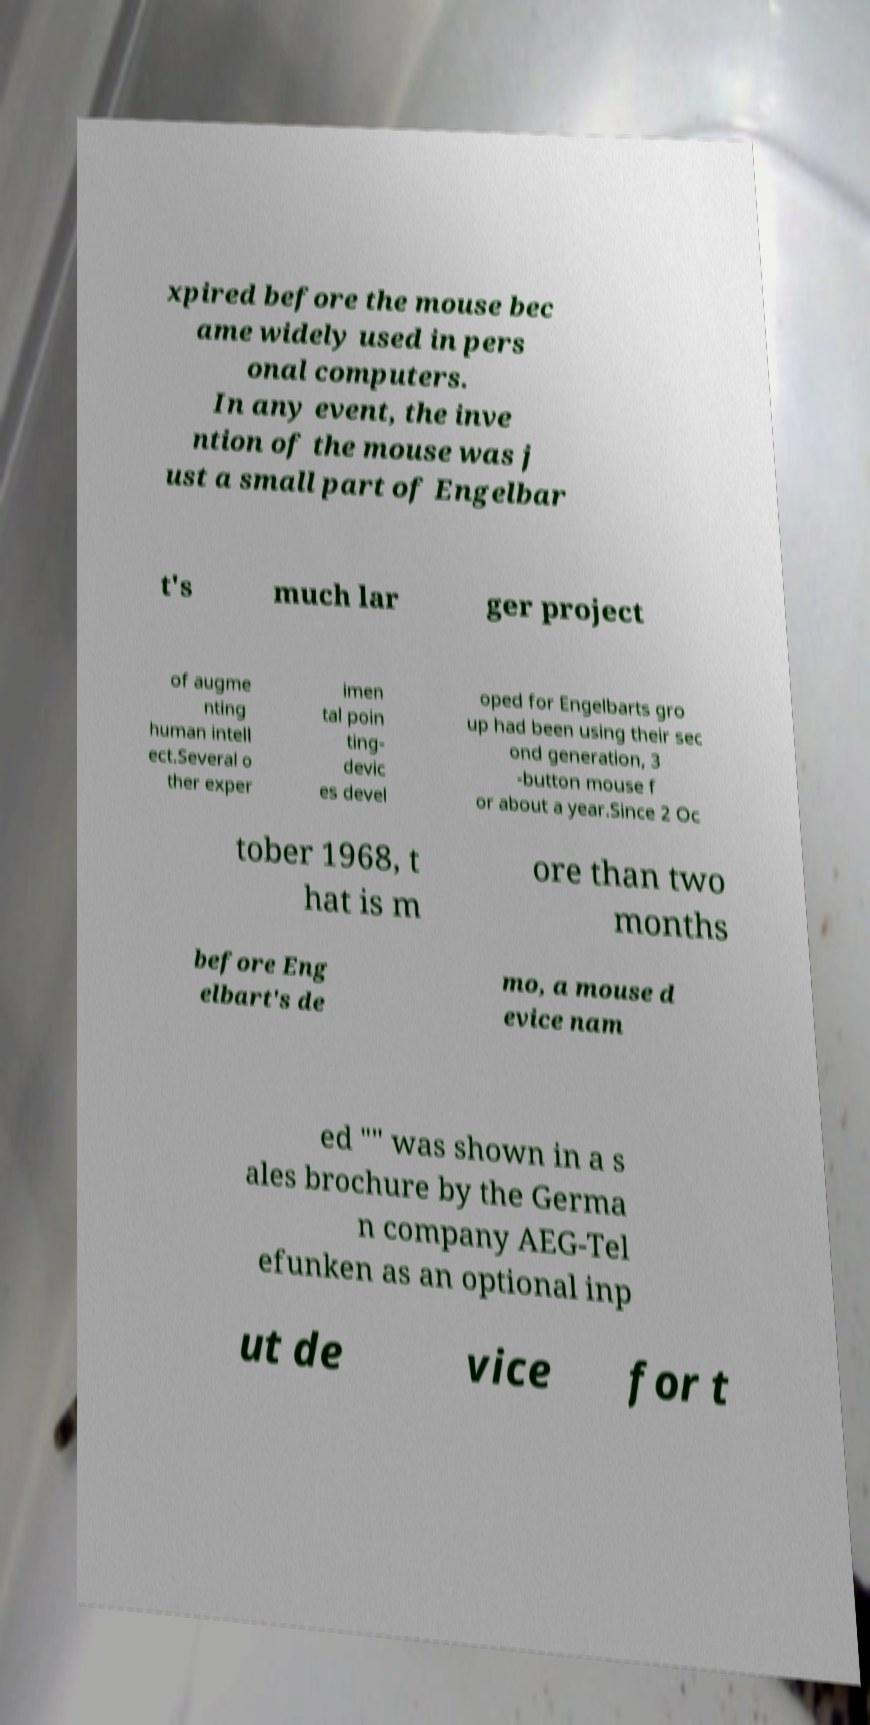For documentation purposes, I need the text within this image transcribed. Could you provide that? xpired before the mouse bec ame widely used in pers onal computers. In any event, the inve ntion of the mouse was j ust a small part of Engelbar t's much lar ger project of augme nting human intell ect.Several o ther exper imen tal poin ting- devic es devel oped for Engelbarts gro up had been using their sec ond generation, 3 -button mouse f or about a year.Since 2 Oc tober 1968, t hat is m ore than two months before Eng elbart's de mo, a mouse d evice nam ed "" was shown in a s ales brochure by the Germa n company AEG-Tel efunken as an optional inp ut de vice for t 